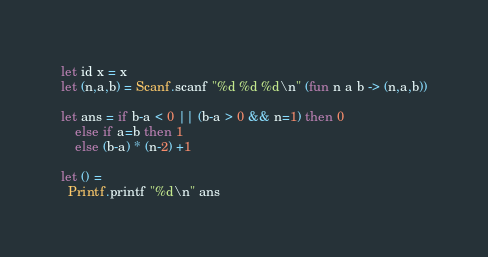Convert code to text. <code><loc_0><loc_0><loc_500><loc_500><_OCaml_>let id x = x
let (n,a,b) = Scanf.scanf "%d %d %d\n" (fun n a b -> (n,a,b))
 
let ans = if b-a < 0 || (b-a > 0 && n=1) then 0
    else if a=b then 1
    else (b-a) * (n-2) +1

let () =
  Printf.printf "%d\n" ans</code> 